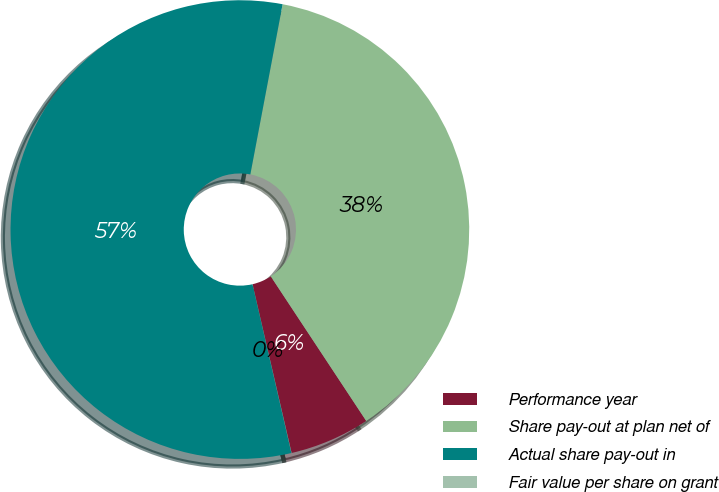<chart> <loc_0><loc_0><loc_500><loc_500><pie_chart><fcel>Performance year<fcel>Share pay-out at plan net of<fcel>Actual share pay-out in<fcel>Fair value per share on grant<nl><fcel>5.67%<fcel>37.73%<fcel>56.6%<fcel>0.01%<nl></chart> 